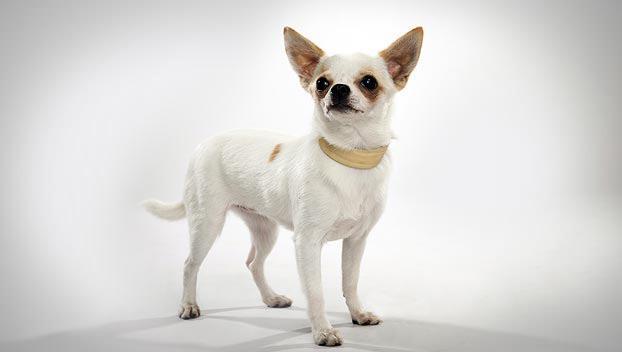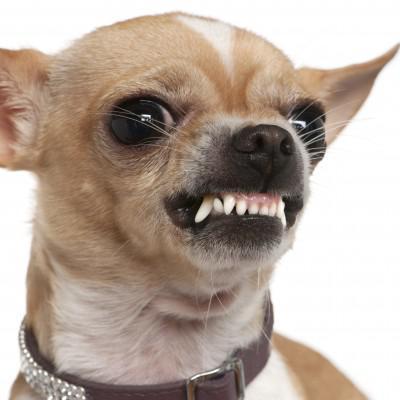The first image is the image on the left, the second image is the image on the right. Analyze the images presented: Is the assertion "There is a chihuahua on grass facing to the right and also a chihua with a darker colouring." valid? Answer yes or no. No. The first image is the image on the left, the second image is the image on the right. Considering the images on both sides, is "At least one dog is wearing a collar." valid? Answer yes or no. Yes. 